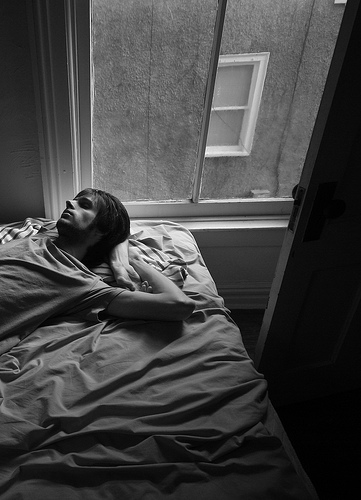Who is lying in the bed? A guy is lying in the bed. 